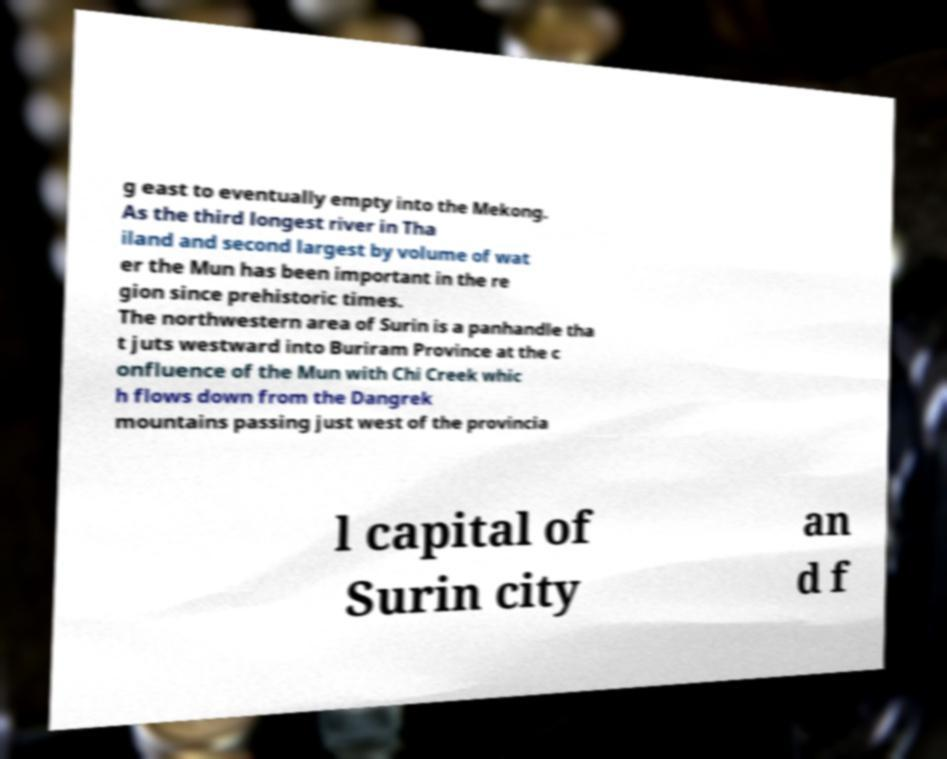There's text embedded in this image that I need extracted. Can you transcribe it verbatim? g east to eventually empty into the Mekong. As the third longest river in Tha iland and second largest by volume of wat er the Mun has been important in the re gion since prehistoric times. The northwestern area of Surin is a panhandle tha t juts westward into Buriram Province at the c onfluence of the Mun with Chi Creek whic h flows down from the Dangrek mountains passing just west of the provincia l capital of Surin city an d f 